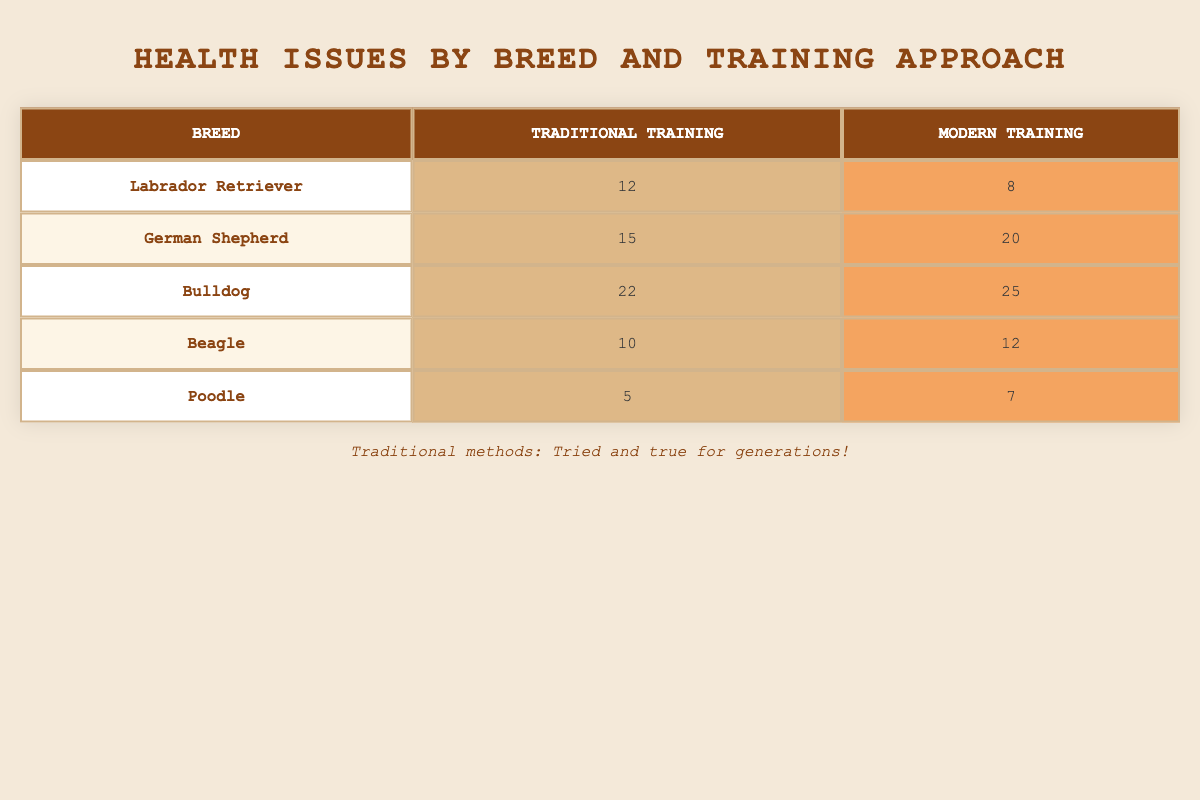What is the health issue count for the Bulldog with Traditional training? The table shows that the Bulldog has a health issue count of 22 when trained with Traditional methods.
Answer: 22 Which breed has the highest reported health issues under Modern training? Looking at the Modern training column, the Bulldog has the highest reported health issues at 25.
Answer: Bulldog What is the difference in the reported health issues between Labrador Retrievers trained traditionally and modernly? For Labrador Retrievers, Traditional training has 12 health issues and Modern training has 8. The difference is 12 - 8 = 4.
Answer: 4 Is it true that the Poodle has fewer health issues when trained traditionally compared to the Beagle? The Poodle has 5 health issues under Traditional training and the Beagle has 10. Since 5 is less than 10, the statement is true.
Answer: Yes What is the average number of health issues reported for Traditional training across all breeds listed? The health issues reported for Traditional training are 12, 15, 22, 10, and 5. Summing these gives 12 + 15 + 22 + 10 + 5 = 64. There are 5 breeds, so the average is 64 / 5 = 12.8.
Answer: 12.8 